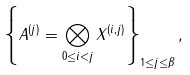<formula> <loc_0><loc_0><loc_500><loc_500>\left \{ A ^ { ( j ) } = \bigotimes _ { 0 \leq i < j } X ^ { ( i , j ) } \right \} _ { 1 \leq j \leq \beta } ,</formula> 